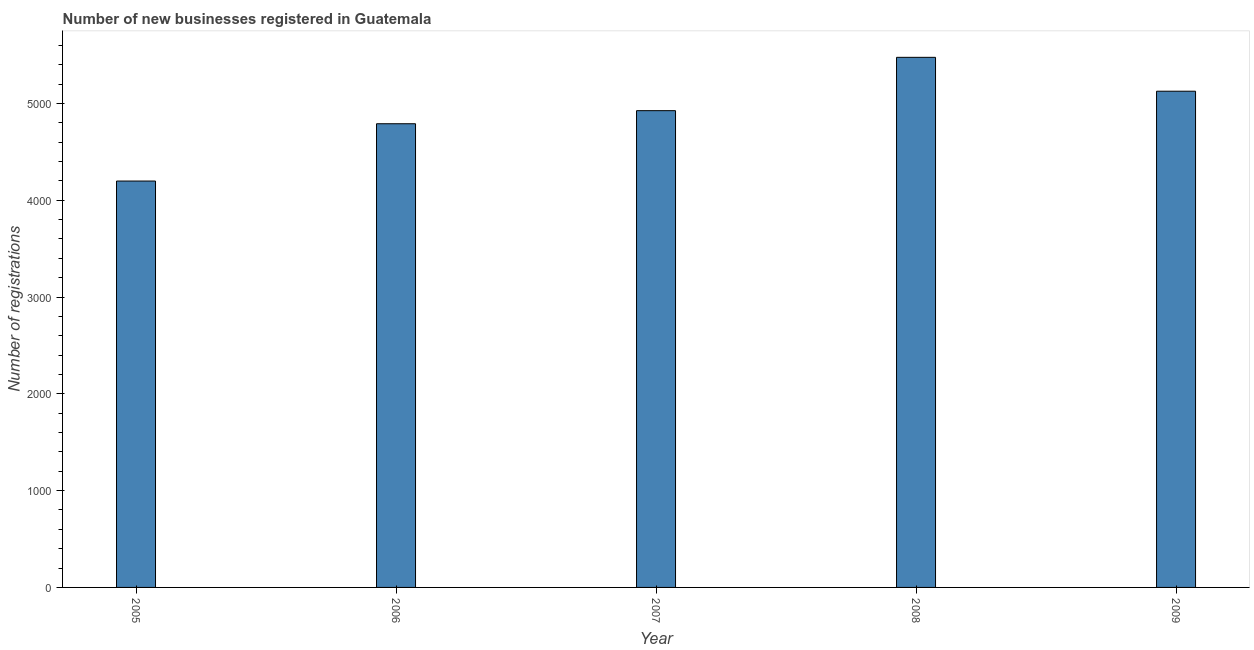Does the graph contain any zero values?
Give a very brief answer. No. What is the title of the graph?
Keep it short and to the point. Number of new businesses registered in Guatemala. What is the label or title of the X-axis?
Your answer should be very brief. Year. What is the label or title of the Y-axis?
Offer a terse response. Number of registrations. What is the number of new business registrations in 2007?
Ensure brevity in your answer.  4925. Across all years, what is the maximum number of new business registrations?
Keep it short and to the point. 5476. Across all years, what is the minimum number of new business registrations?
Offer a very short reply. 4198. What is the sum of the number of new business registrations?
Make the answer very short. 2.45e+04. What is the difference between the number of new business registrations in 2005 and 2008?
Offer a very short reply. -1278. What is the average number of new business registrations per year?
Ensure brevity in your answer.  4903. What is the median number of new business registrations?
Your response must be concise. 4925. In how many years, is the number of new business registrations greater than 200 ?
Your answer should be very brief. 5. What is the ratio of the number of new business registrations in 2007 to that in 2008?
Provide a short and direct response. 0.9. What is the difference between the highest and the second highest number of new business registrations?
Give a very brief answer. 350. Is the sum of the number of new business registrations in 2007 and 2009 greater than the maximum number of new business registrations across all years?
Make the answer very short. Yes. What is the difference between the highest and the lowest number of new business registrations?
Offer a very short reply. 1278. How many bars are there?
Ensure brevity in your answer.  5. Are all the bars in the graph horizontal?
Give a very brief answer. No. What is the difference between two consecutive major ticks on the Y-axis?
Offer a very short reply. 1000. What is the Number of registrations of 2005?
Your response must be concise. 4198. What is the Number of registrations of 2006?
Give a very brief answer. 4790. What is the Number of registrations in 2007?
Make the answer very short. 4925. What is the Number of registrations in 2008?
Provide a succinct answer. 5476. What is the Number of registrations in 2009?
Give a very brief answer. 5126. What is the difference between the Number of registrations in 2005 and 2006?
Provide a short and direct response. -592. What is the difference between the Number of registrations in 2005 and 2007?
Give a very brief answer. -727. What is the difference between the Number of registrations in 2005 and 2008?
Your response must be concise. -1278. What is the difference between the Number of registrations in 2005 and 2009?
Give a very brief answer. -928. What is the difference between the Number of registrations in 2006 and 2007?
Keep it short and to the point. -135. What is the difference between the Number of registrations in 2006 and 2008?
Give a very brief answer. -686. What is the difference between the Number of registrations in 2006 and 2009?
Offer a very short reply. -336. What is the difference between the Number of registrations in 2007 and 2008?
Offer a very short reply. -551. What is the difference between the Number of registrations in 2007 and 2009?
Ensure brevity in your answer.  -201. What is the difference between the Number of registrations in 2008 and 2009?
Provide a short and direct response. 350. What is the ratio of the Number of registrations in 2005 to that in 2006?
Make the answer very short. 0.88. What is the ratio of the Number of registrations in 2005 to that in 2007?
Your answer should be very brief. 0.85. What is the ratio of the Number of registrations in 2005 to that in 2008?
Provide a succinct answer. 0.77. What is the ratio of the Number of registrations in 2005 to that in 2009?
Give a very brief answer. 0.82. What is the ratio of the Number of registrations in 2006 to that in 2009?
Provide a succinct answer. 0.93. What is the ratio of the Number of registrations in 2007 to that in 2008?
Give a very brief answer. 0.9. What is the ratio of the Number of registrations in 2008 to that in 2009?
Provide a succinct answer. 1.07. 